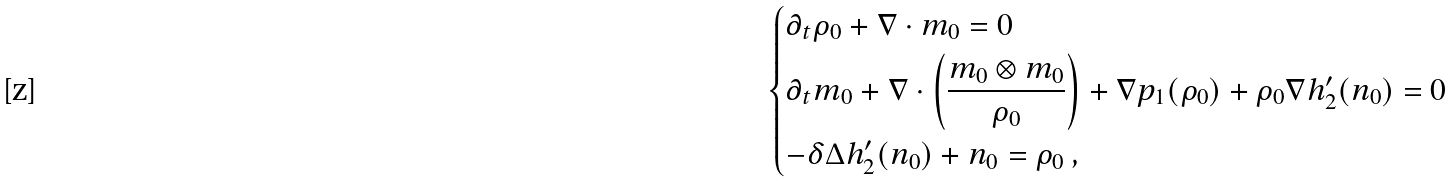Convert formula to latex. <formula><loc_0><loc_0><loc_500><loc_500>\begin{dcases} \partial _ { t } \rho _ { 0 } + \nabla \cdot m _ { 0 } = 0 \\ \partial _ { t } m _ { 0 } + \nabla \cdot \left ( \frac { m _ { 0 } \otimes m _ { 0 } } { \rho _ { 0 } } \right ) + \nabla p _ { 1 } ( \rho _ { 0 } ) + \rho _ { 0 } \nabla h _ { 2 } ^ { \prime } ( n _ { 0 } ) = 0 \\ - \delta \Delta h _ { 2 } ^ { \prime } ( n _ { 0 } ) + n _ { 0 } = \rho _ { 0 } \ , \end{dcases}</formula> 